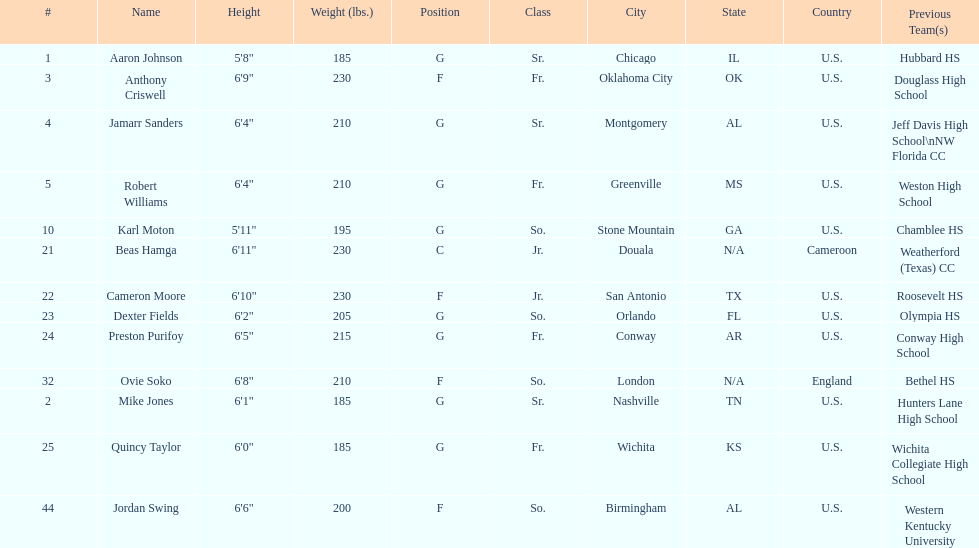Who is the tallest player on the team? Beas Hamga. 